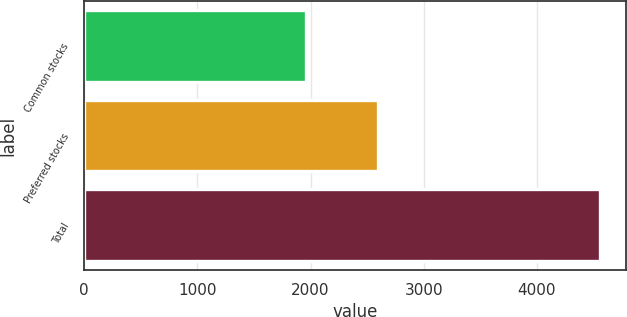Convert chart. <chart><loc_0><loc_0><loc_500><loc_500><bar_chart><fcel>Common stocks<fcel>Preferred stocks<fcel>Total<nl><fcel>1960<fcel>2597<fcel>4557<nl></chart> 